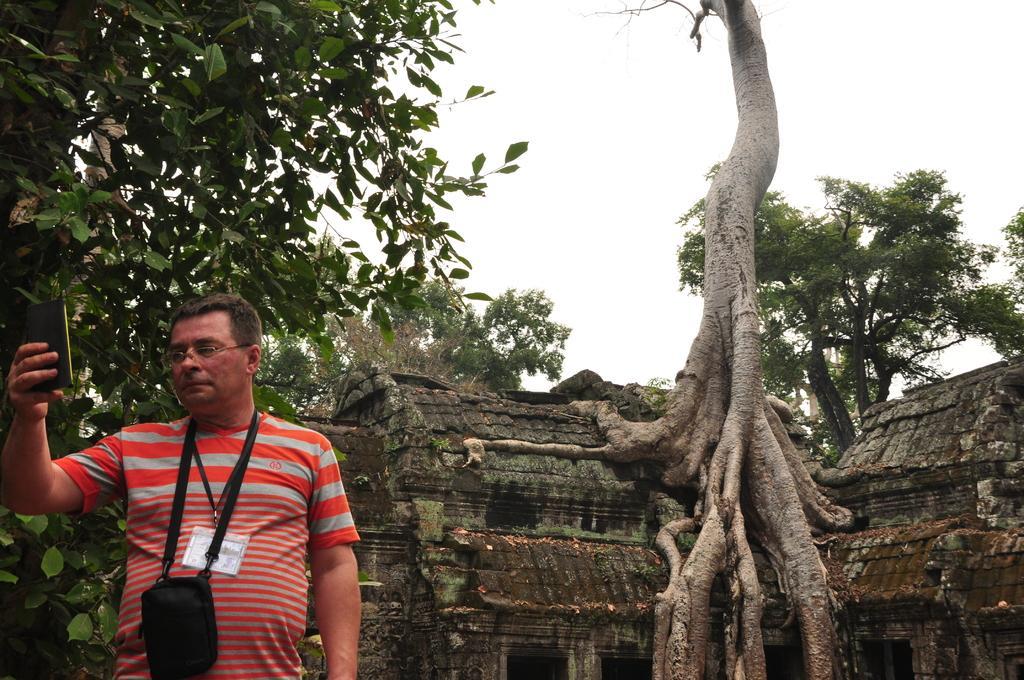How would you summarize this image in a sentence or two? In this image there is a person holding a mobile phone in his hand looks into it, behind the person there are trees and an old house. 